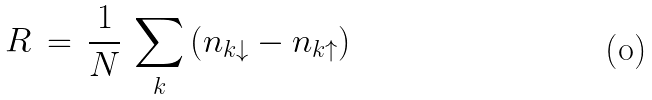Convert formula to latex. <formula><loc_0><loc_0><loc_500><loc_500>R \, = \, \frac { 1 } { N } \, \sum _ { k } \left ( n _ { k \downarrow } - n _ { k \uparrow } \right )</formula> 